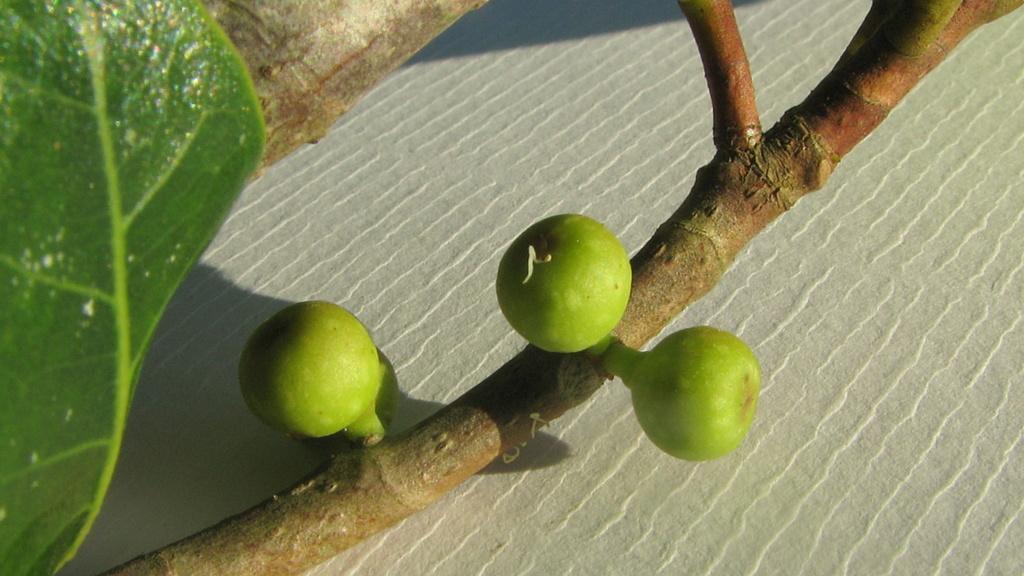Please provide a concise description of this image. This picture shows a tree branch with a leaf and we see fruits to it. 